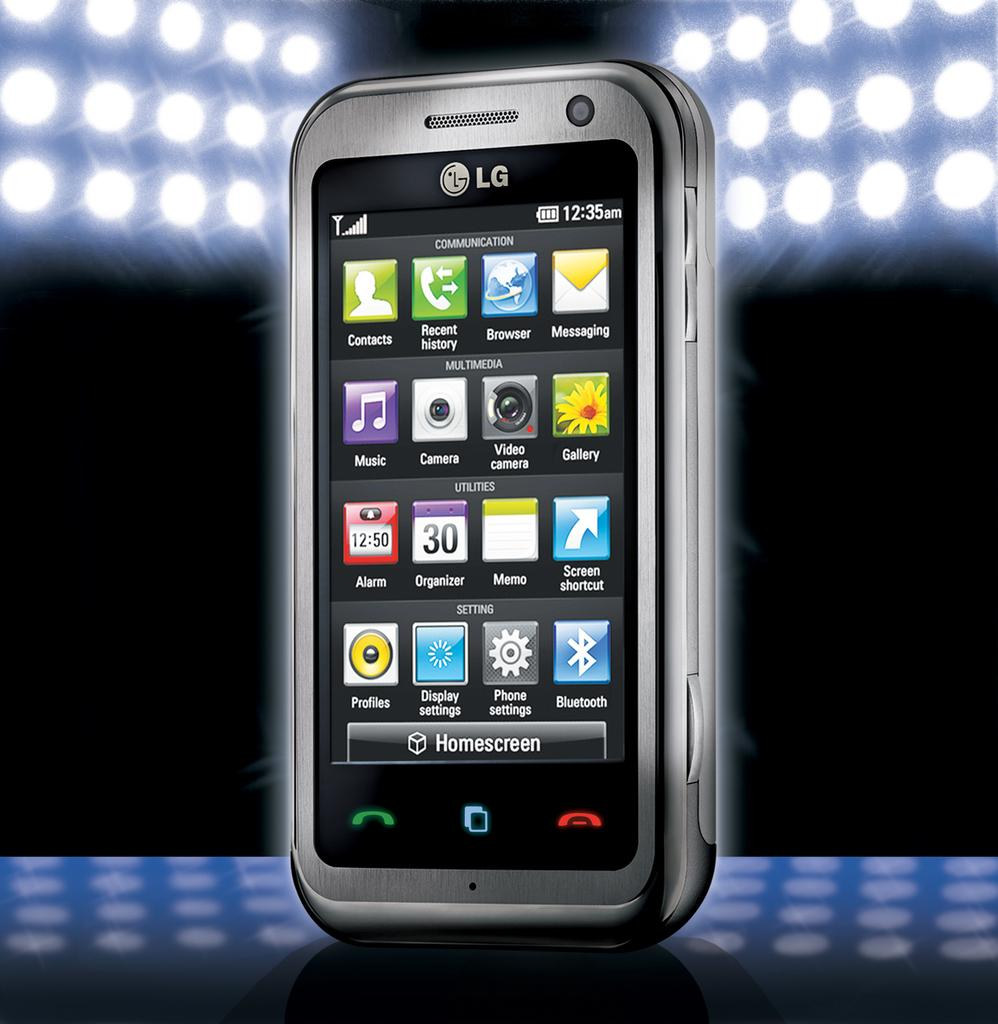<image>
Provide a brief description of the given image. The LG smart phone show 16 different icons on it. 